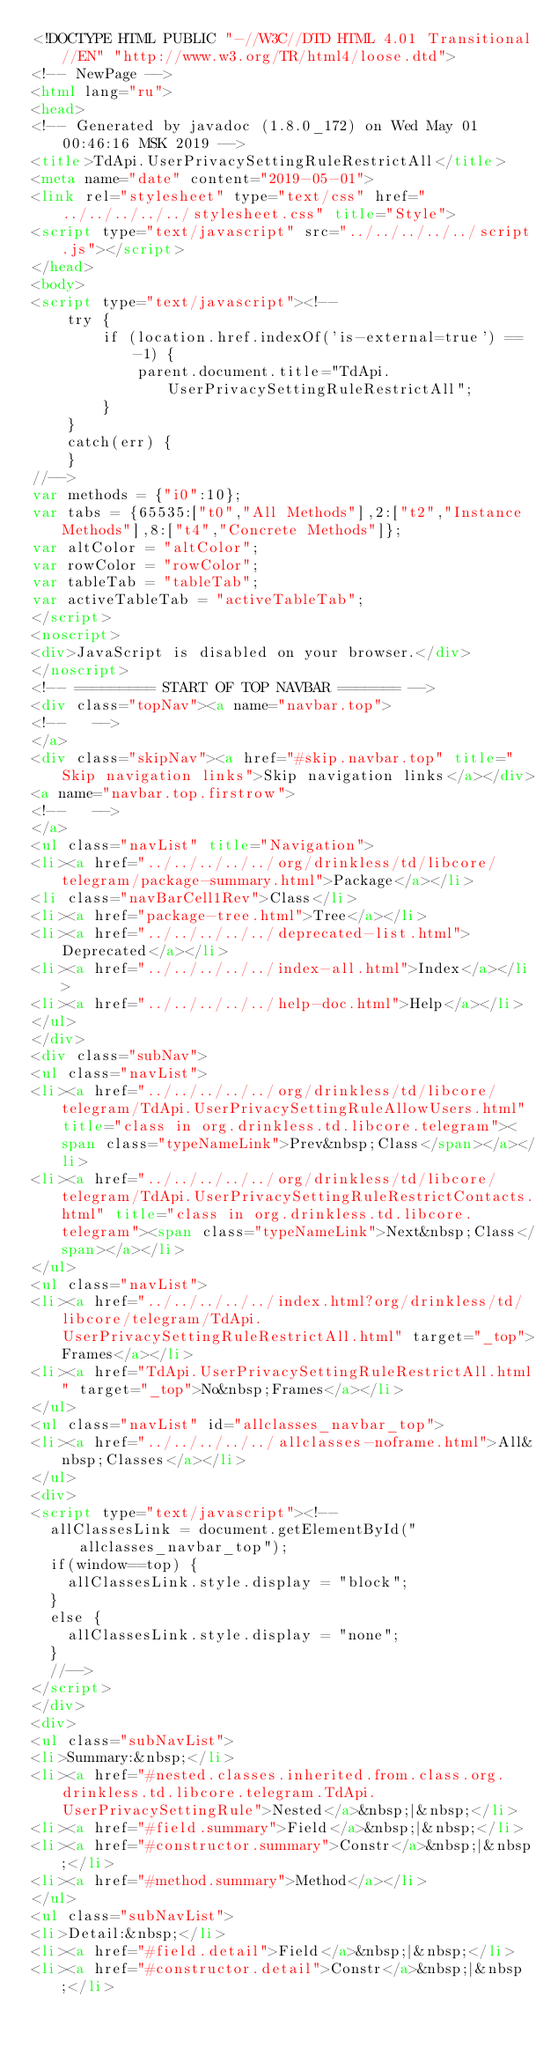Convert code to text. <code><loc_0><loc_0><loc_500><loc_500><_HTML_><!DOCTYPE HTML PUBLIC "-//W3C//DTD HTML 4.01 Transitional//EN" "http://www.w3.org/TR/html4/loose.dtd">
<!-- NewPage -->
<html lang="ru">
<head>
<!-- Generated by javadoc (1.8.0_172) on Wed May 01 00:46:16 MSK 2019 -->
<title>TdApi.UserPrivacySettingRuleRestrictAll</title>
<meta name="date" content="2019-05-01">
<link rel="stylesheet" type="text/css" href="../../../../../stylesheet.css" title="Style">
<script type="text/javascript" src="../../../../../script.js"></script>
</head>
<body>
<script type="text/javascript"><!--
    try {
        if (location.href.indexOf('is-external=true') == -1) {
            parent.document.title="TdApi.UserPrivacySettingRuleRestrictAll";
        }
    }
    catch(err) {
    }
//-->
var methods = {"i0":10};
var tabs = {65535:["t0","All Methods"],2:["t2","Instance Methods"],8:["t4","Concrete Methods"]};
var altColor = "altColor";
var rowColor = "rowColor";
var tableTab = "tableTab";
var activeTableTab = "activeTableTab";
</script>
<noscript>
<div>JavaScript is disabled on your browser.</div>
</noscript>
<!-- ========= START OF TOP NAVBAR ======= -->
<div class="topNav"><a name="navbar.top">
<!--   -->
</a>
<div class="skipNav"><a href="#skip.navbar.top" title="Skip navigation links">Skip navigation links</a></div>
<a name="navbar.top.firstrow">
<!--   -->
</a>
<ul class="navList" title="Navigation">
<li><a href="../../../../../org/drinkless/td/libcore/telegram/package-summary.html">Package</a></li>
<li class="navBarCell1Rev">Class</li>
<li><a href="package-tree.html">Tree</a></li>
<li><a href="../../../../../deprecated-list.html">Deprecated</a></li>
<li><a href="../../../../../index-all.html">Index</a></li>
<li><a href="../../../../../help-doc.html">Help</a></li>
</ul>
</div>
<div class="subNav">
<ul class="navList">
<li><a href="../../../../../org/drinkless/td/libcore/telegram/TdApi.UserPrivacySettingRuleAllowUsers.html" title="class in org.drinkless.td.libcore.telegram"><span class="typeNameLink">Prev&nbsp;Class</span></a></li>
<li><a href="../../../../../org/drinkless/td/libcore/telegram/TdApi.UserPrivacySettingRuleRestrictContacts.html" title="class in org.drinkless.td.libcore.telegram"><span class="typeNameLink">Next&nbsp;Class</span></a></li>
</ul>
<ul class="navList">
<li><a href="../../../../../index.html?org/drinkless/td/libcore/telegram/TdApi.UserPrivacySettingRuleRestrictAll.html" target="_top">Frames</a></li>
<li><a href="TdApi.UserPrivacySettingRuleRestrictAll.html" target="_top">No&nbsp;Frames</a></li>
</ul>
<ul class="navList" id="allclasses_navbar_top">
<li><a href="../../../../../allclasses-noframe.html">All&nbsp;Classes</a></li>
</ul>
<div>
<script type="text/javascript"><!--
  allClassesLink = document.getElementById("allclasses_navbar_top");
  if(window==top) {
    allClassesLink.style.display = "block";
  }
  else {
    allClassesLink.style.display = "none";
  }
  //-->
</script>
</div>
<div>
<ul class="subNavList">
<li>Summary:&nbsp;</li>
<li><a href="#nested.classes.inherited.from.class.org.drinkless.td.libcore.telegram.TdApi.UserPrivacySettingRule">Nested</a>&nbsp;|&nbsp;</li>
<li><a href="#field.summary">Field</a>&nbsp;|&nbsp;</li>
<li><a href="#constructor.summary">Constr</a>&nbsp;|&nbsp;</li>
<li><a href="#method.summary">Method</a></li>
</ul>
<ul class="subNavList">
<li>Detail:&nbsp;</li>
<li><a href="#field.detail">Field</a>&nbsp;|&nbsp;</li>
<li><a href="#constructor.detail">Constr</a>&nbsp;|&nbsp;</li></code> 